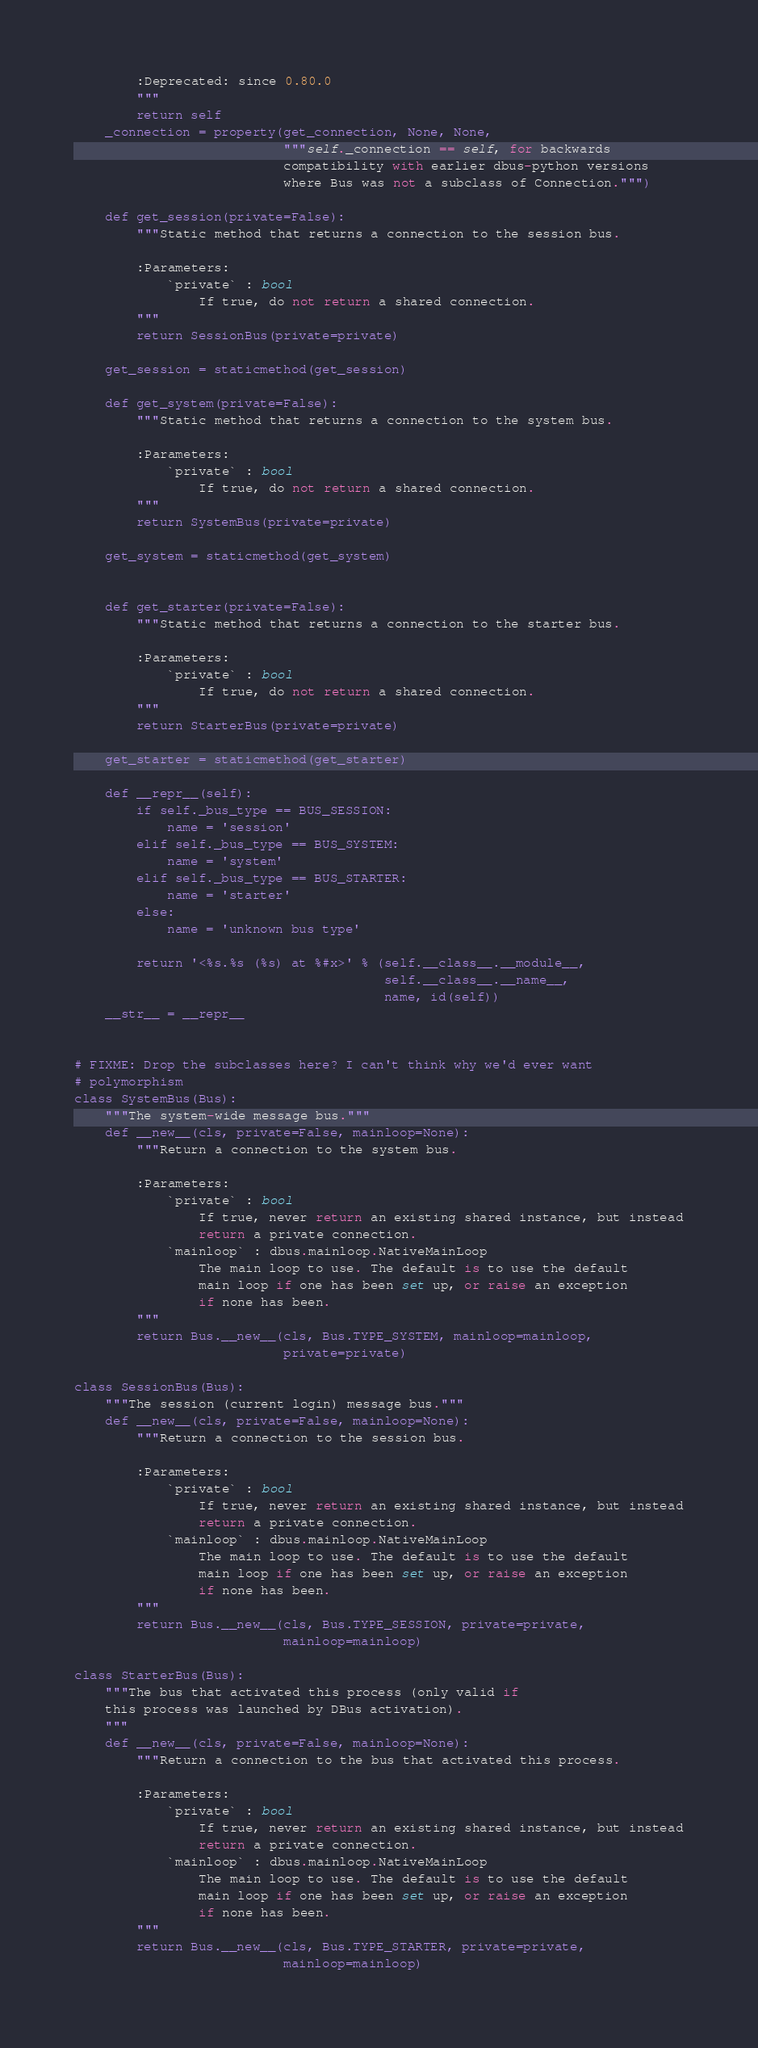<code> <loc_0><loc_0><loc_500><loc_500><_Python_>
        :Deprecated: since 0.80.0
        """
        return self
    _connection = property(get_connection, None, None,
                           """self._connection == self, for backwards
                           compatibility with earlier dbus-python versions
                           where Bus was not a subclass of Connection.""")

    def get_session(private=False):
        """Static method that returns a connection to the session bus.

        :Parameters:
            `private` : bool
                If true, do not return a shared connection.
        """
        return SessionBus(private=private)

    get_session = staticmethod(get_session)

    def get_system(private=False):
        """Static method that returns a connection to the system bus.

        :Parameters:
            `private` : bool
                If true, do not return a shared connection.
        """
        return SystemBus(private=private)

    get_system = staticmethod(get_system)


    def get_starter(private=False):
        """Static method that returns a connection to the starter bus.

        :Parameters:
            `private` : bool
                If true, do not return a shared connection.
        """
        return StarterBus(private=private)

    get_starter = staticmethod(get_starter)

    def __repr__(self):
        if self._bus_type == BUS_SESSION:
            name = 'session'
        elif self._bus_type == BUS_SYSTEM:
            name = 'system'
        elif self._bus_type == BUS_STARTER:
            name = 'starter'
        else:
            name = 'unknown bus type'

        return '<%s.%s (%s) at %#x>' % (self.__class__.__module__,
                                        self.__class__.__name__,
                                        name, id(self))
    __str__ = __repr__


# FIXME: Drop the subclasses here? I can't think why we'd ever want
# polymorphism
class SystemBus(Bus):
    """The system-wide message bus."""
    def __new__(cls, private=False, mainloop=None):
        """Return a connection to the system bus.

        :Parameters:
            `private` : bool
                If true, never return an existing shared instance, but instead
                return a private connection.
            `mainloop` : dbus.mainloop.NativeMainLoop
                The main loop to use. The default is to use the default
                main loop if one has been set up, or raise an exception
                if none has been.
        """
        return Bus.__new__(cls, Bus.TYPE_SYSTEM, mainloop=mainloop,
                           private=private)

class SessionBus(Bus):
    """The session (current login) message bus."""
    def __new__(cls, private=False, mainloop=None):
        """Return a connection to the session bus.

        :Parameters:
            `private` : bool
                If true, never return an existing shared instance, but instead
                return a private connection.
            `mainloop` : dbus.mainloop.NativeMainLoop
                The main loop to use. The default is to use the default
                main loop if one has been set up, or raise an exception
                if none has been.
        """
        return Bus.__new__(cls, Bus.TYPE_SESSION, private=private,
                           mainloop=mainloop)

class StarterBus(Bus):
    """The bus that activated this process (only valid if
    this process was launched by DBus activation).
    """
    def __new__(cls, private=False, mainloop=None):
        """Return a connection to the bus that activated this process.

        :Parameters:
            `private` : bool
                If true, never return an existing shared instance, but instead
                return a private connection.
            `mainloop` : dbus.mainloop.NativeMainLoop
                The main loop to use. The default is to use the default
                main loop if one has been set up, or raise an exception
                if none has been.
        """
        return Bus.__new__(cls, Bus.TYPE_STARTER, private=private,
                           mainloop=mainloop)
</code> 